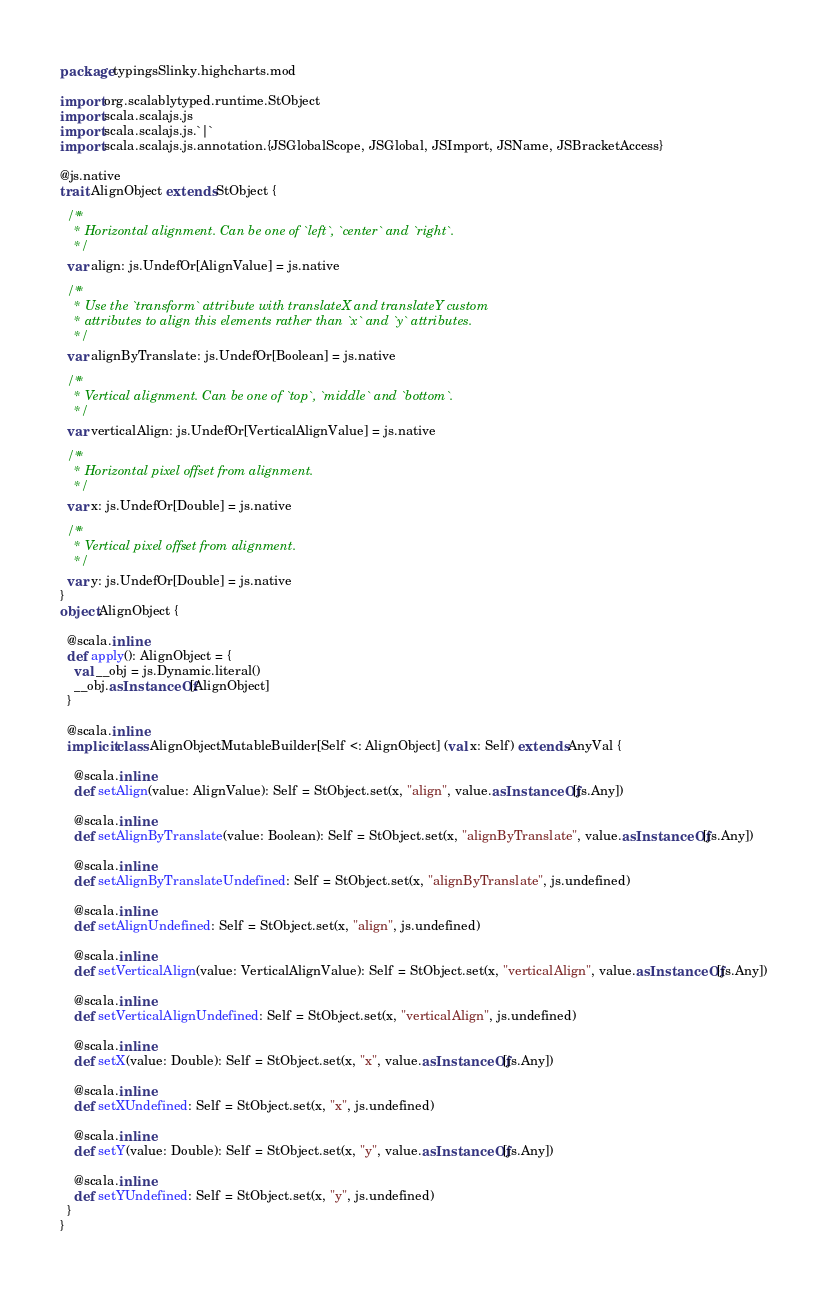Convert code to text. <code><loc_0><loc_0><loc_500><loc_500><_Scala_>package typingsSlinky.highcharts.mod

import org.scalablytyped.runtime.StObject
import scala.scalajs.js
import scala.scalajs.js.`|`
import scala.scalajs.js.annotation.{JSGlobalScope, JSGlobal, JSImport, JSName, JSBracketAccess}

@js.native
trait AlignObject extends StObject {
  
  /**
    * Horizontal alignment. Can be one of `left`, `center` and `right`.
    */
  var align: js.UndefOr[AlignValue] = js.native
  
  /**
    * Use the `transform` attribute with translateX and translateY custom
    * attributes to align this elements rather than `x` and `y` attributes.
    */
  var alignByTranslate: js.UndefOr[Boolean] = js.native
  
  /**
    * Vertical alignment. Can be one of `top`, `middle` and `bottom`.
    */
  var verticalAlign: js.UndefOr[VerticalAlignValue] = js.native
  
  /**
    * Horizontal pixel offset from alignment.
    */
  var x: js.UndefOr[Double] = js.native
  
  /**
    * Vertical pixel offset from alignment.
    */
  var y: js.UndefOr[Double] = js.native
}
object AlignObject {
  
  @scala.inline
  def apply(): AlignObject = {
    val __obj = js.Dynamic.literal()
    __obj.asInstanceOf[AlignObject]
  }
  
  @scala.inline
  implicit class AlignObjectMutableBuilder[Self <: AlignObject] (val x: Self) extends AnyVal {
    
    @scala.inline
    def setAlign(value: AlignValue): Self = StObject.set(x, "align", value.asInstanceOf[js.Any])
    
    @scala.inline
    def setAlignByTranslate(value: Boolean): Self = StObject.set(x, "alignByTranslate", value.asInstanceOf[js.Any])
    
    @scala.inline
    def setAlignByTranslateUndefined: Self = StObject.set(x, "alignByTranslate", js.undefined)
    
    @scala.inline
    def setAlignUndefined: Self = StObject.set(x, "align", js.undefined)
    
    @scala.inline
    def setVerticalAlign(value: VerticalAlignValue): Self = StObject.set(x, "verticalAlign", value.asInstanceOf[js.Any])
    
    @scala.inline
    def setVerticalAlignUndefined: Self = StObject.set(x, "verticalAlign", js.undefined)
    
    @scala.inline
    def setX(value: Double): Self = StObject.set(x, "x", value.asInstanceOf[js.Any])
    
    @scala.inline
    def setXUndefined: Self = StObject.set(x, "x", js.undefined)
    
    @scala.inline
    def setY(value: Double): Self = StObject.set(x, "y", value.asInstanceOf[js.Any])
    
    @scala.inline
    def setYUndefined: Self = StObject.set(x, "y", js.undefined)
  }
}
</code> 